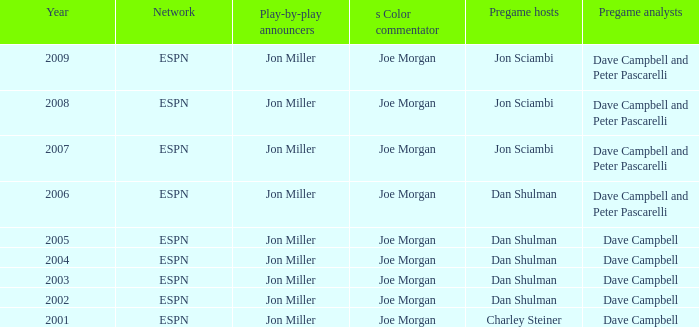In 2008, how many networks were listed? 1.0. 